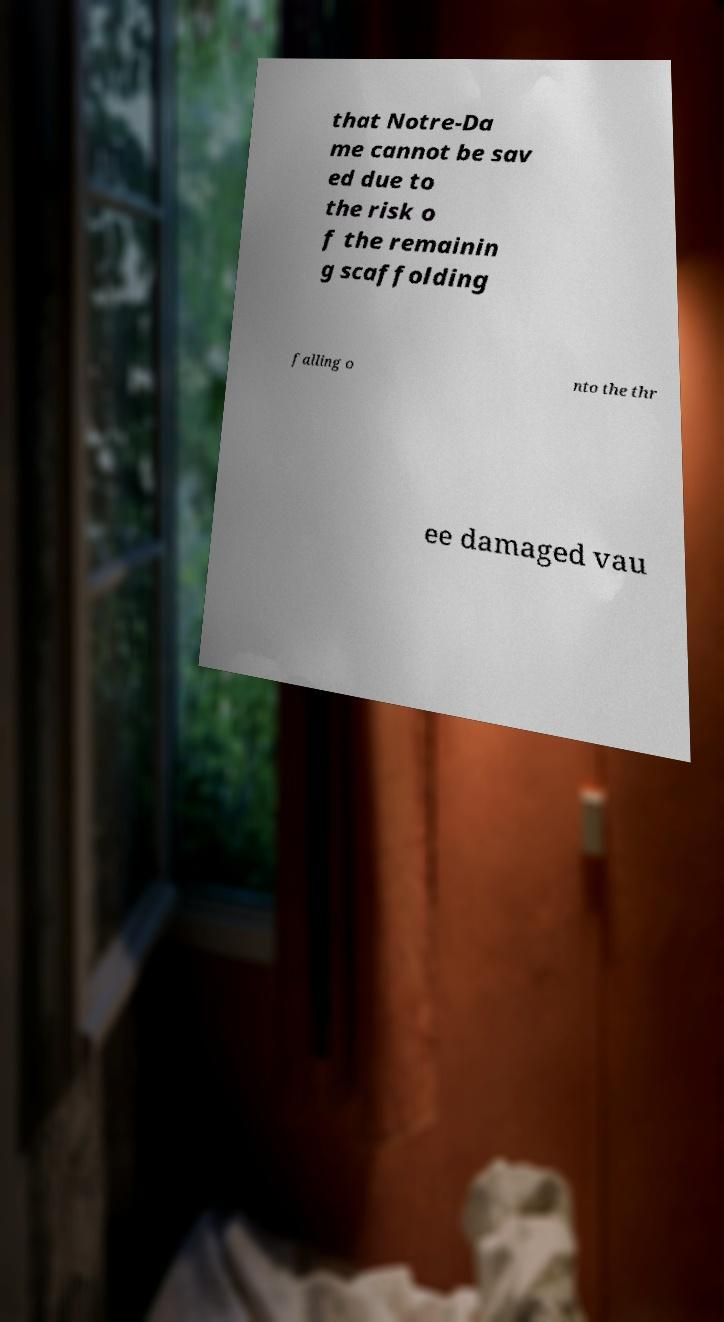Can you read and provide the text displayed in the image?This photo seems to have some interesting text. Can you extract and type it out for me? that Notre-Da me cannot be sav ed due to the risk o f the remainin g scaffolding falling o nto the thr ee damaged vau 